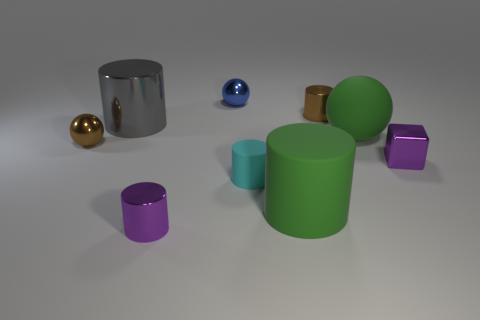Subtract all green cylinders. How many cylinders are left? 4 Subtract all green rubber cylinders. How many cylinders are left? 4 Subtract 1 cylinders. How many cylinders are left? 4 Subtract all red cylinders. Subtract all brown balls. How many cylinders are left? 5 Subtract all cylinders. How many objects are left? 4 Subtract 1 green cylinders. How many objects are left? 8 Subtract all tiny blue metal cubes. Subtract all big green rubber cylinders. How many objects are left? 8 Add 1 rubber things. How many rubber things are left? 4 Add 1 small purple metallic objects. How many small purple metallic objects exist? 3 